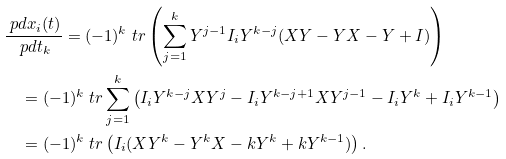<formula> <loc_0><loc_0><loc_500><loc_500>& \frac { \ p d x _ { i } ( t ) } { \ p d t _ { k } } = ( - 1 ) ^ { k } \ t r \left ( \sum _ { j = 1 } ^ { k } Y ^ { j - 1 } I _ { i } Y ^ { k - j } ( X Y - Y X - Y + I ) \right ) \\ & \quad = ( - 1 ) ^ { k } \ t r \sum _ { j = 1 } ^ { k } \left ( I _ { i } Y ^ { k - j } X Y ^ { j } - I _ { i } Y ^ { k - j + 1 } X Y ^ { j - 1 } - I _ { i } Y ^ { k } + I _ { i } Y ^ { k - 1 } \right ) \\ & \quad = ( - 1 ) ^ { k } \ t r \left ( I _ { i } ( X Y ^ { k } - Y ^ { k } X - k Y ^ { k } + k Y ^ { k - 1 } ) \right ) .</formula> 